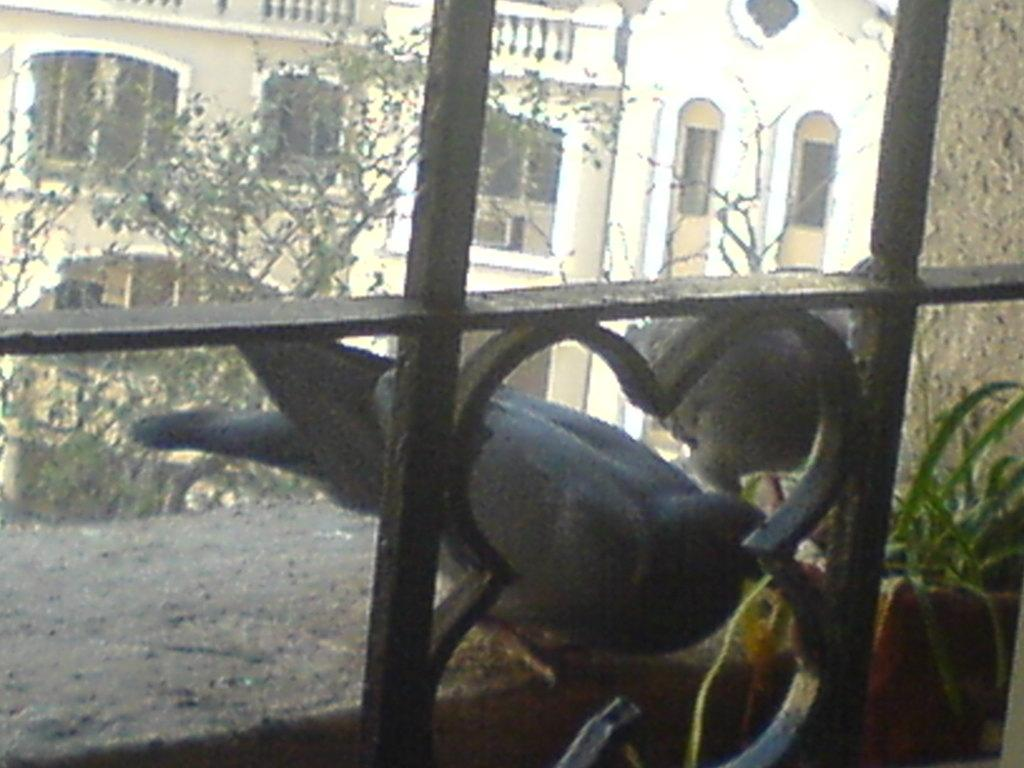What animal can be seen near the window in the image? There is a pigeon at the window in the image. What type of plant is visible in the image? There is a house plant in the image. What can be seen in the background of the image? There are trees and buildings with windows in the background of the image. How many wristbands does the pigeon have in the image? There are no wristbands present in the image, as the subject is a pigeon and wristbands are not applicable to birds. How many mice can be seen running around the house plant in the image? There are no mice present in the image; the only animals mentioned are the pigeon at the window and the house plant. 